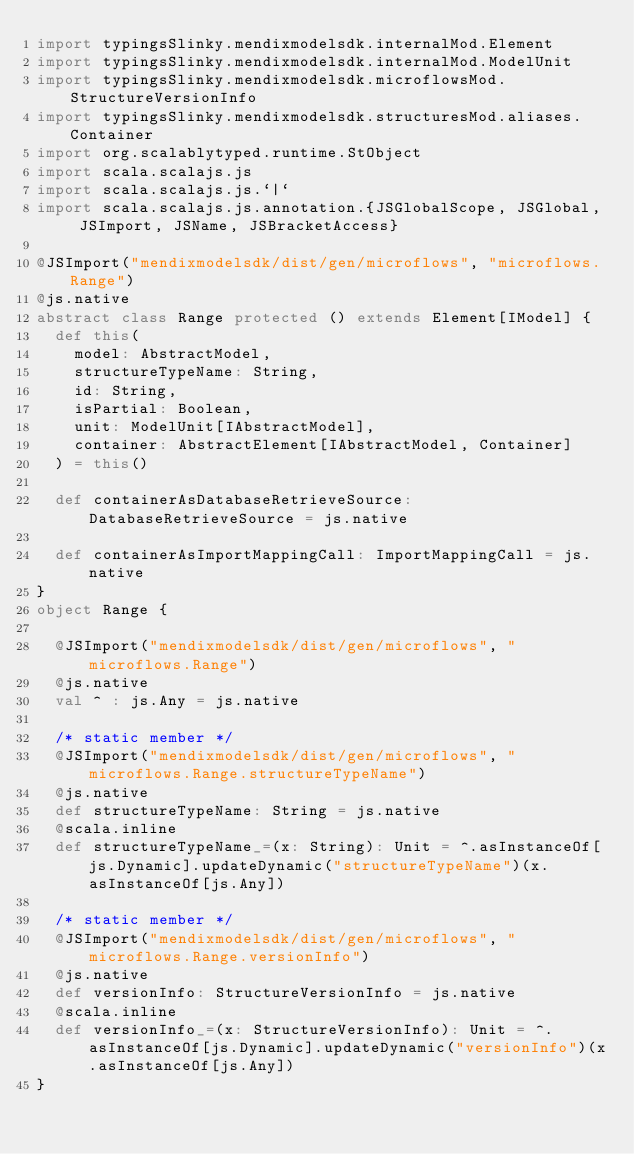Convert code to text. <code><loc_0><loc_0><loc_500><loc_500><_Scala_>import typingsSlinky.mendixmodelsdk.internalMod.Element
import typingsSlinky.mendixmodelsdk.internalMod.ModelUnit
import typingsSlinky.mendixmodelsdk.microflowsMod.StructureVersionInfo
import typingsSlinky.mendixmodelsdk.structuresMod.aliases.Container
import org.scalablytyped.runtime.StObject
import scala.scalajs.js
import scala.scalajs.js.`|`
import scala.scalajs.js.annotation.{JSGlobalScope, JSGlobal, JSImport, JSName, JSBracketAccess}

@JSImport("mendixmodelsdk/dist/gen/microflows", "microflows.Range")
@js.native
abstract class Range protected () extends Element[IModel] {
  def this(
    model: AbstractModel,
    structureTypeName: String,
    id: String,
    isPartial: Boolean,
    unit: ModelUnit[IAbstractModel],
    container: AbstractElement[IAbstractModel, Container]
  ) = this()
  
  def containerAsDatabaseRetrieveSource: DatabaseRetrieveSource = js.native
  
  def containerAsImportMappingCall: ImportMappingCall = js.native
}
object Range {
  
  @JSImport("mendixmodelsdk/dist/gen/microflows", "microflows.Range")
  @js.native
  val ^ : js.Any = js.native
  
  /* static member */
  @JSImport("mendixmodelsdk/dist/gen/microflows", "microflows.Range.structureTypeName")
  @js.native
  def structureTypeName: String = js.native
  @scala.inline
  def structureTypeName_=(x: String): Unit = ^.asInstanceOf[js.Dynamic].updateDynamic("structureTypeName")(x.asInstanceOf[js.Any])
  
  /* static member */
  @JSImport("mendixmodelsdk/dist/gen/microflows", "microflows.Range.versionInfo")
  @js.native
  def versionInfo: StructureVersionInfo = js.native
  @scala.inline
  def versionInfo_=(x: StructureVersionInfo): Unit = ^.asInstanceOf[js.Dynamic].updateDynamic("versionInfo")(x.asInstanceOf[js.Any])
}
</code> 